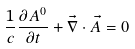<formula> <loc_0><loc_0><loc_500><loc_500>\frac { 1 } { c } \frac { \partial A ^ { 0 } } { \partial t } + \vec { \nabla } \cdot \vec { A } = 0</formula> 